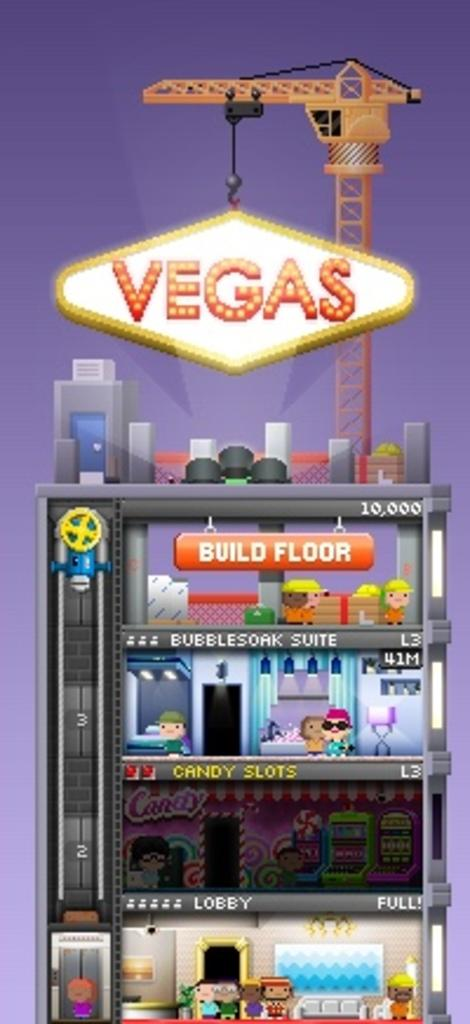What is the main subject of the animation in the image? The main subject of the animation in the image is a fridge. Are there any words or phrases written on the image? Yes, there is text written on the image. What additional object can be seen on the upper surface of the image? There is a crane on the upper surface of the image. Can you see a rifle in the image? No, there is no rifle present in the image. What trick is being performed by the fridge in the animation? The image does not depict a trick being performed by the fridge; it is simply an animation related to a fridge. 